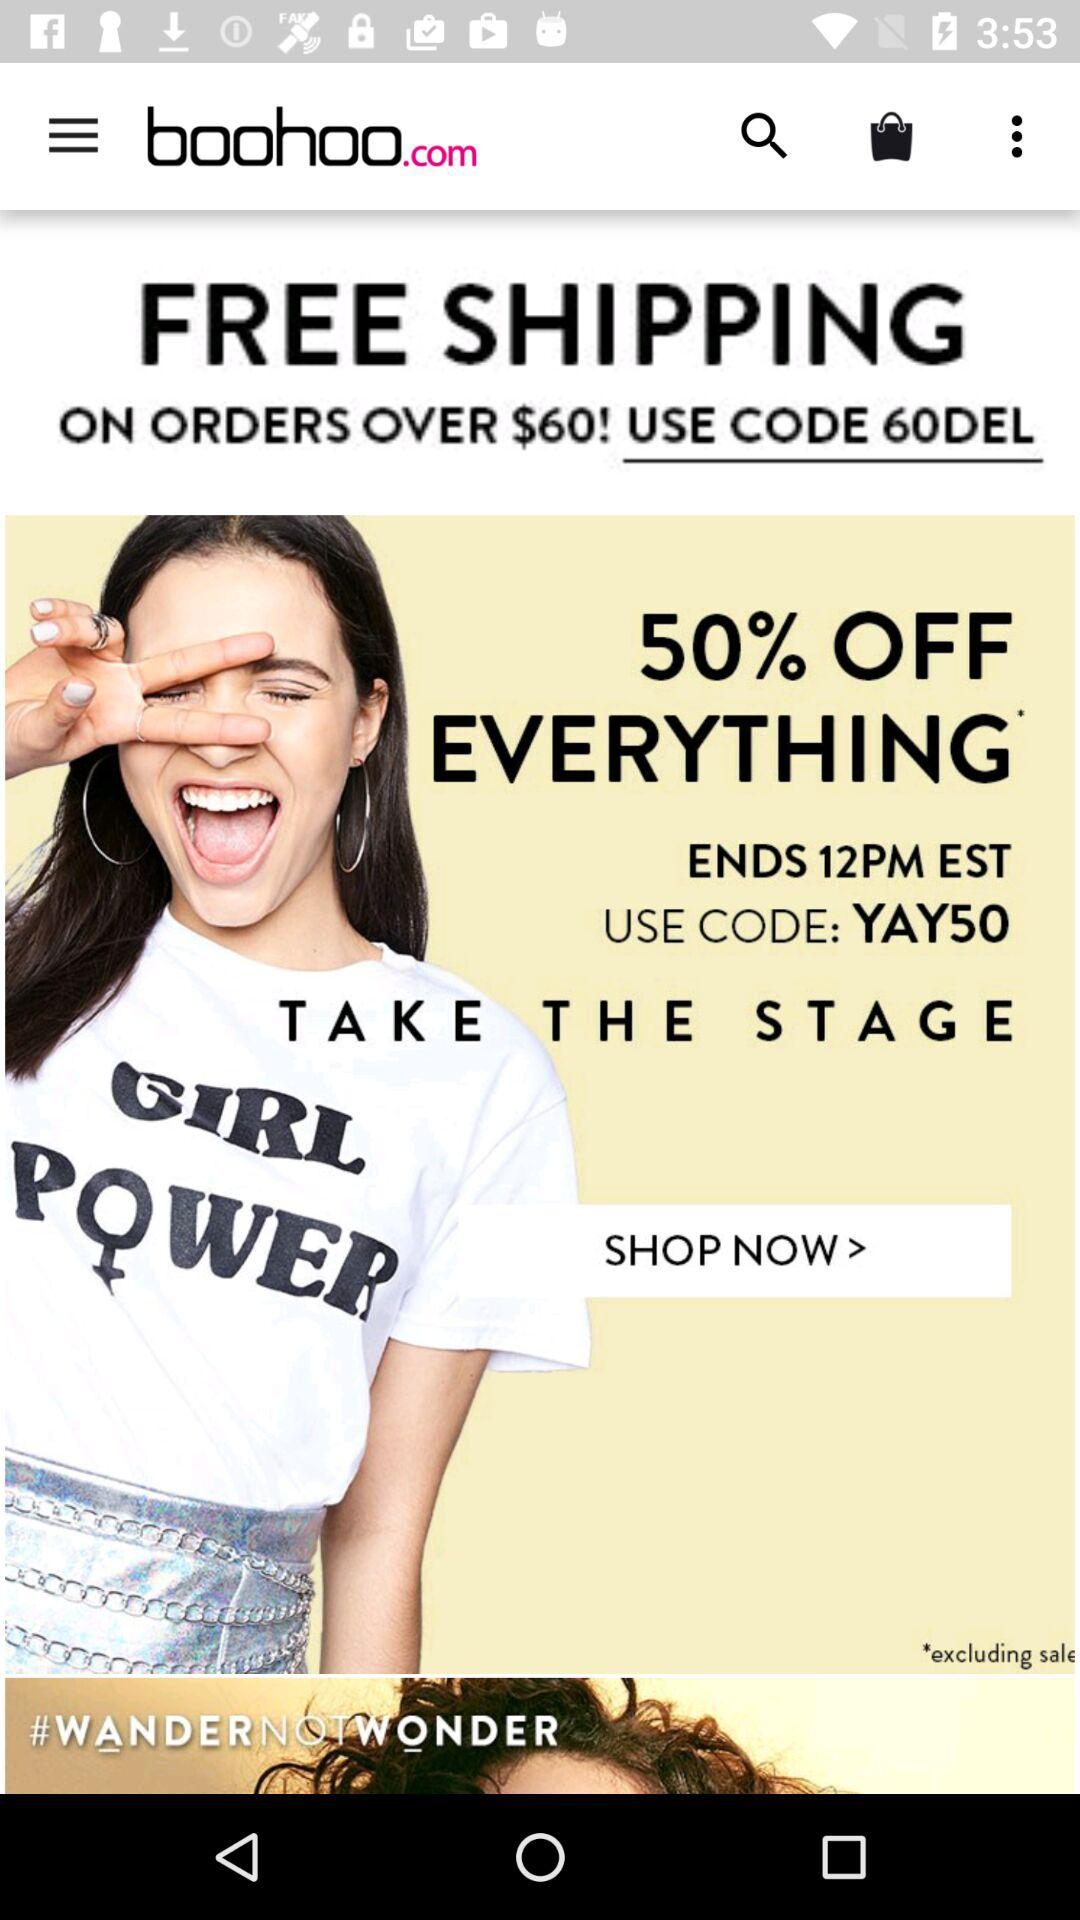What is the code for 50% off? The code for 50% off is "YAY50". 